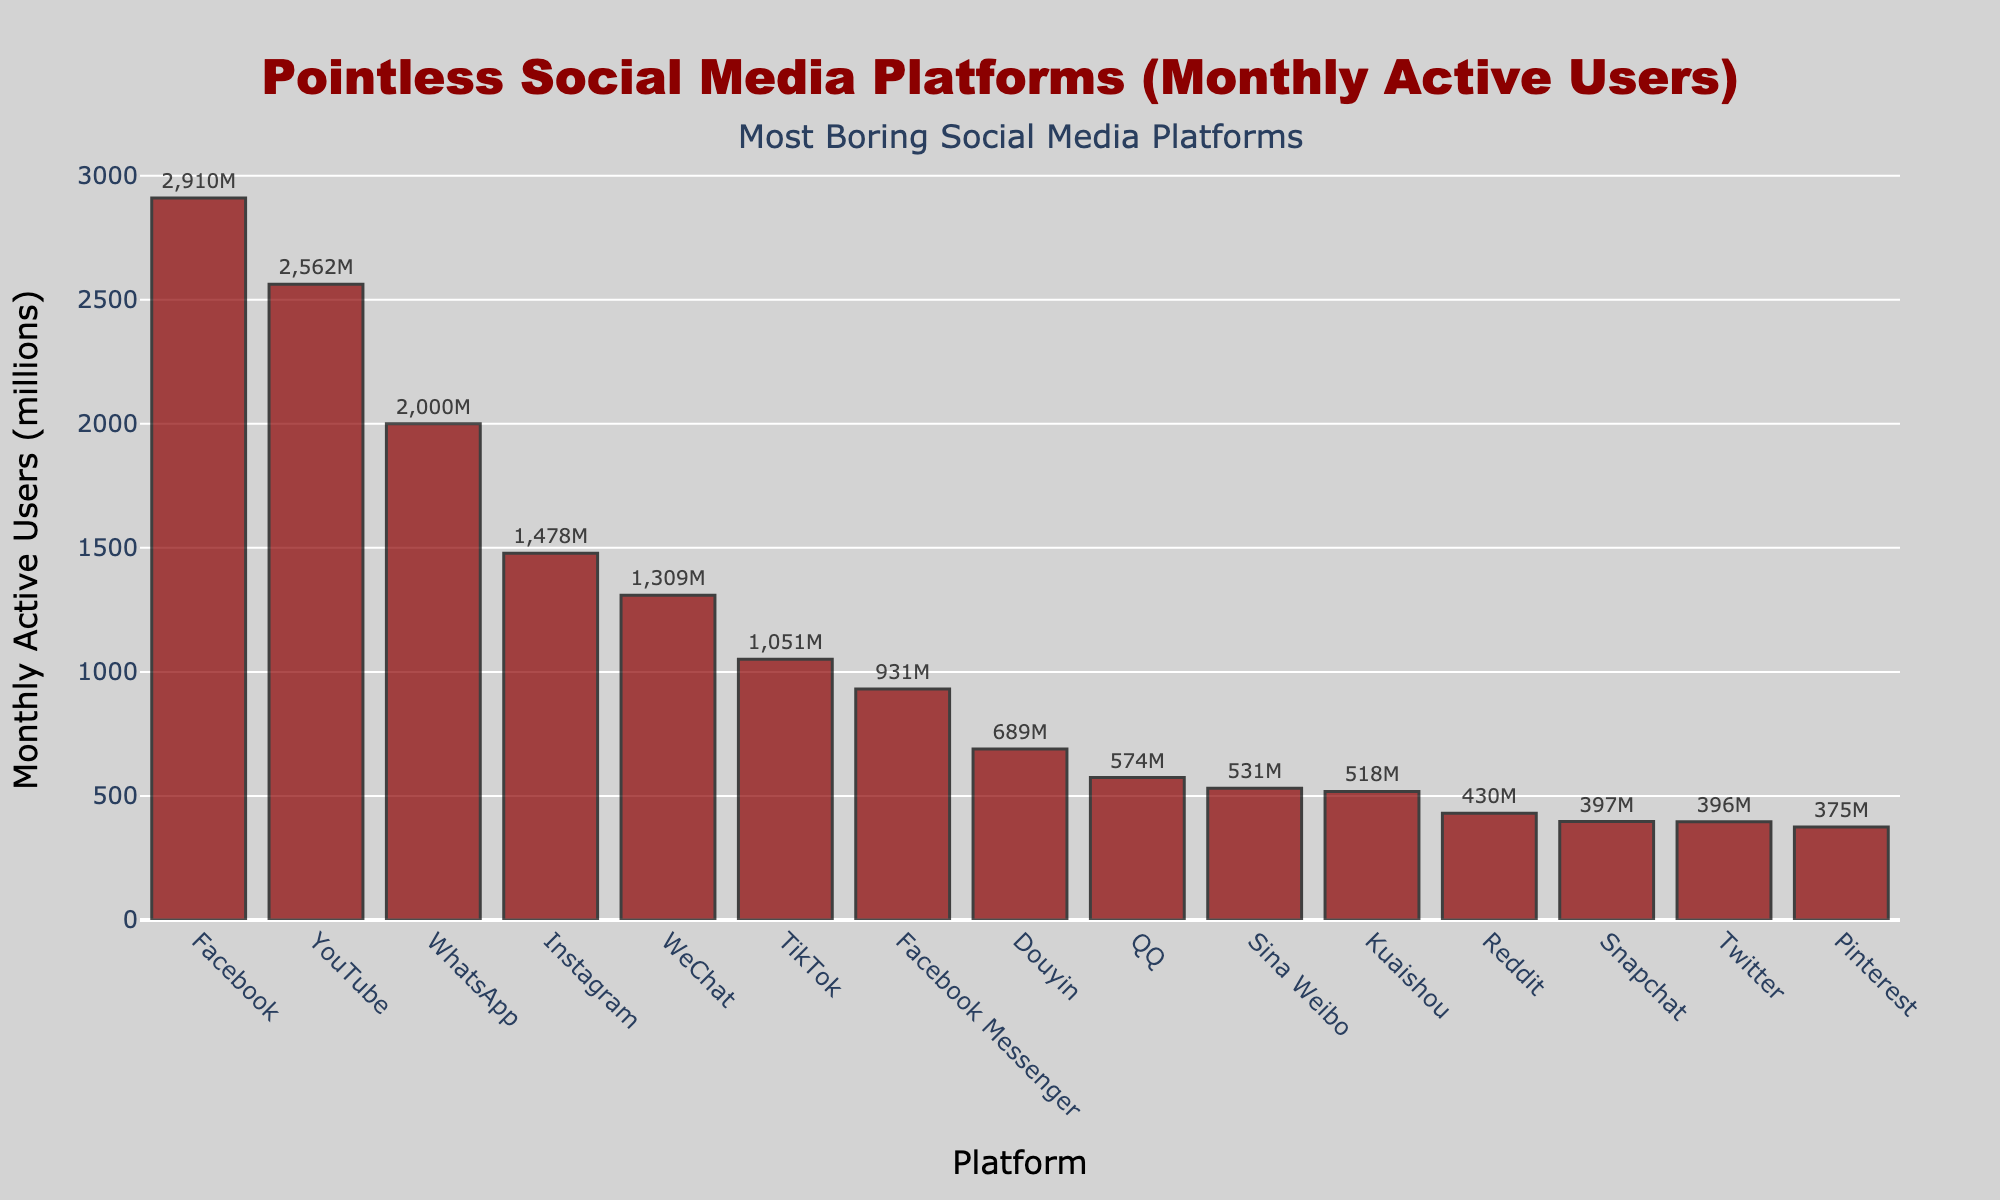What's the platform with the highest number of monthly active users? The bar with the greatest height indicates the platform with the most users. Here, the tallest bar represents Facebook.
Answer: Facebook Which platform has more users, Snapchat or Twitter? Compare the heights of the bars representing Snapchat and Twitter. The bar for Snapchat is slightly taller than Twitter.
Answer: Snapchat How many platforms have more than 1 billion monthly active users? Count the bars that exceed the 1 billion mark on the y-axis. This includes Facebook, YouTube, WhatsApp, Instagram, and WeChat.
Answer: 5 What's the total number of monthly active users for Facebook, Instagram, and WhatsApp combined? Add the values for the respective platforms: 2910 (Facebook) + 1478 (Instagram) + 2000 (WhatsApp) equals 6388 million.
Answer: 6388 million Which is the least popular platform according to the bar chart? The shortest bar represents the least popular platform, which is Twitter with 396 million users.
Answer: Twitter Does Douyin have more monthly active users compared to QQ? Compare the bars for Douyin and QQ. Douyin's bar is taller than QQ's bar.
Answer: Yes What is the difference in monthly active users between YouTube and TikTok? Subtract TikTok’s users from YouTube’s users: 2562 - 1051 equals 1511 million.
Answer: 1511 million What is the average number of monthly active users for Pinterest, Reddit, and Twitter? First, sum the users of Pinterest (375 million), Reddit (430 million), and Twitter (396 million) to get 1201 million. Then, divide by 3: 1201 / 3 equals approximately 400.33 million.
Answer: 400.33 million Which platform has slightly fewer users than WeChat? Identify the bar just below WeChat's bar. The next tallest bar belongs to Instagram with 1478 million users.
Answer: Instagram 